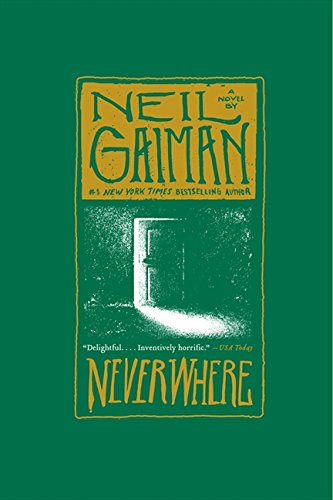Who wrote this book?
Answer the question using a single word or phrase. Neil Gaiman What is the title of this book? Neverwhere: A Novel What is the genre of this book? Science Fiction & Fantasy Is this book related to Science Fiction & Fantasy? Yes Is this book related to Education & Teaching? No 